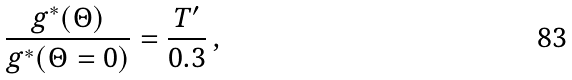<formula> <loc_0><loc_0><loc_500><loc_500>\frac { g ^ { * } ( \Theta ) } { g ^ { * } ( \Theta = 0 ) } = \frac { T ^ { \prime } } { 0 . 3 } \, ,</formula> 